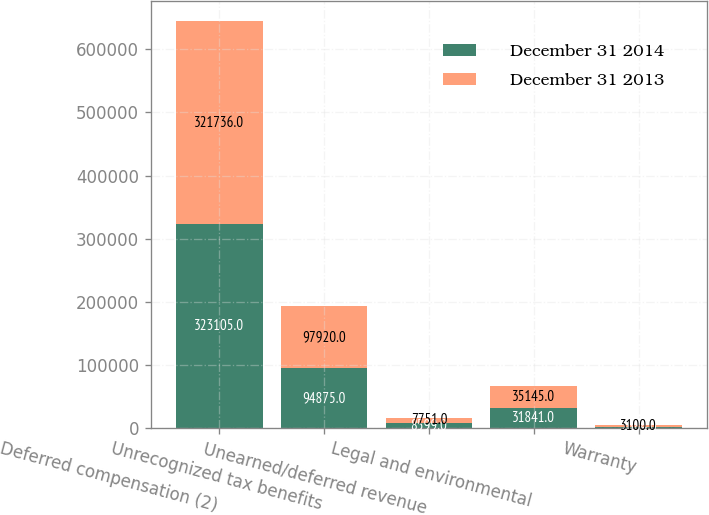<chart> <loc_0><loc_0><loc_500><loc_500><stacked_bar_chart><ecel><fcel>Deferred compensation (2)<fcel>Unrecognized tax benefits<fcel>Unearned/deferred revenue<fcel>Legal and environmental<fcel>Warranty<nl><fcel>December 31 2014<fcel>323105<fcel>94875<fcel>8599<fcel>31841<fcel>2684<nl><fcel>December 31 2013<fcel>321736<fcel>97920<fcel>7751<fcel>35145<fcel>3100<nl></chart> 